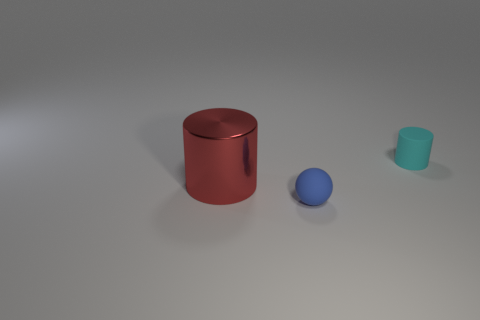What is the material of the large red object that is the same shape as the cyan thing?
Keep it short and to the point. Metal. Is there any other thing that has the same color as the tiny ball?
Your response must be concise. No. What number of cylinders are red objects or tiny rubber things?
Your response must be concise. 2. How many cylinders are both to the right of the large thing and left of the cyan cylinder?
Offer a terse response. 0. Are there the same number of cyan matte things behind the tiny cyan object and tiny things that are behind the big cylinder?
Ensure brevity in your answer.  No. Do the small matte object that is behind the big cylinder and the large thing have the same shape?
Your response must be concise. Yes. What shape is the big thing that is in front of the cylinder that is to the right of the small blue rubber ball in front of the big cylinder?
Offer a terse response. Cylinder. There is a thing that is both behind the ball and in front of the cyan matte thing; what is it made of?
Your response must be concise. Metal. Are there fewer rubber spheres than rubber objects?
Give a very brief answer. Yes. Does the blue thing have the same shape as the large object in front of the small cyan rubber cylinder?
Ensure brevity in your answer.  No. 